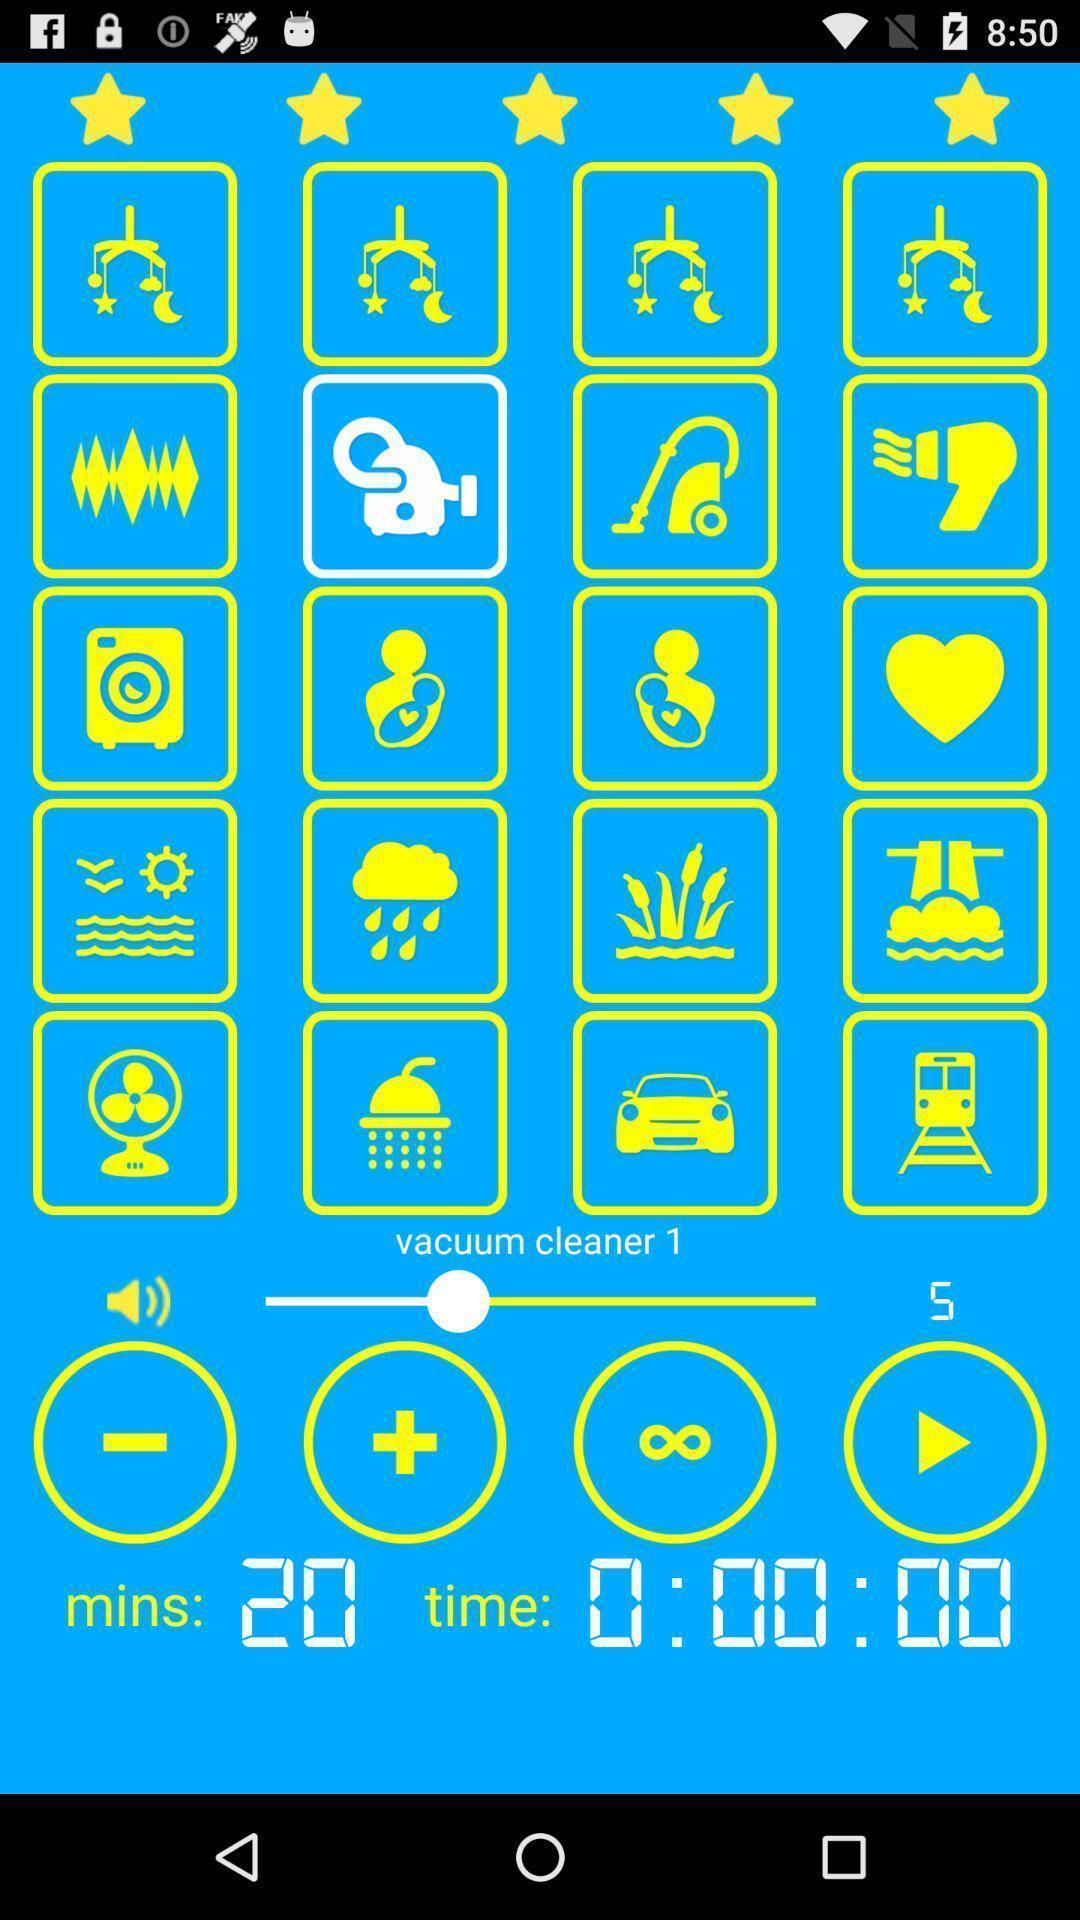Explain what's happening in this screen capture. Various logos timer and other options displayed. 